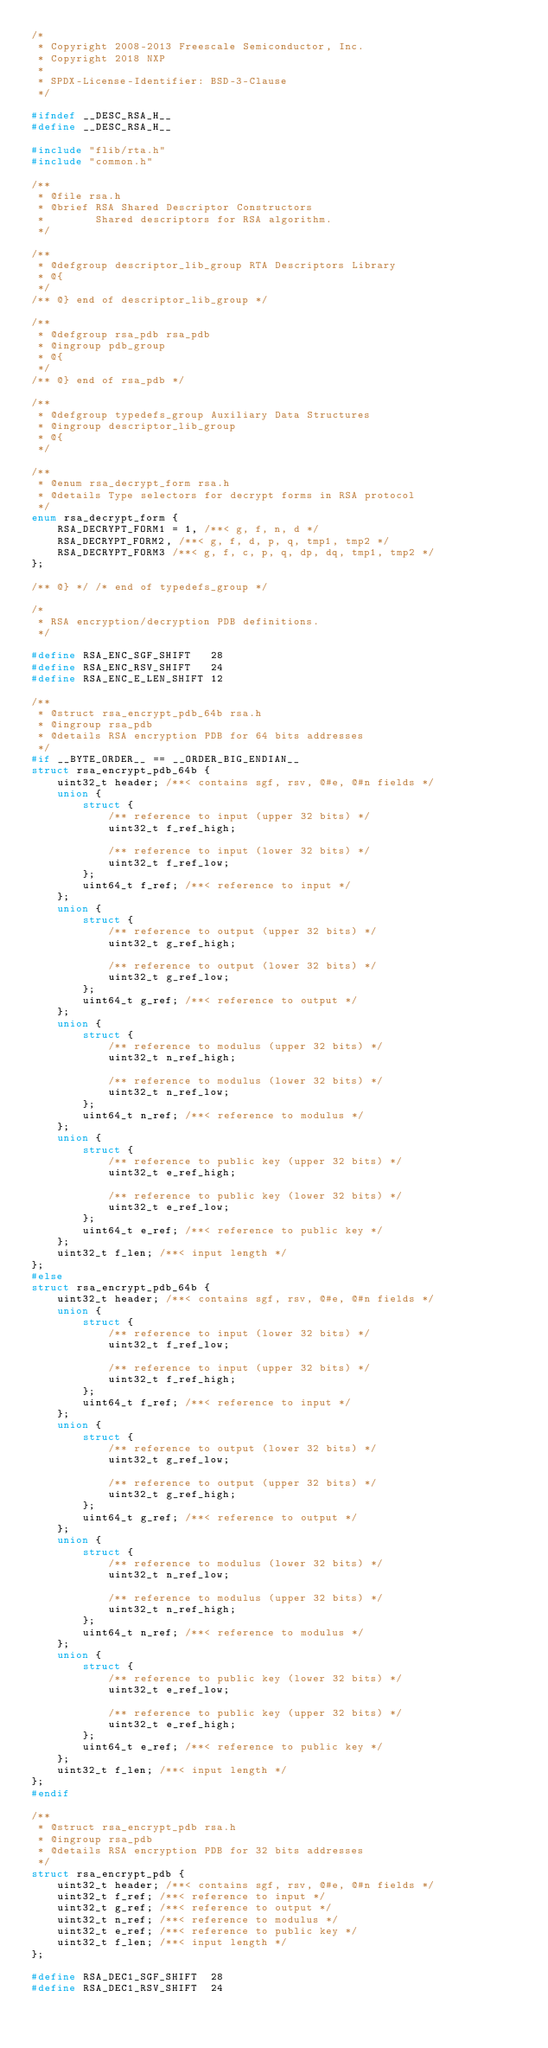<code> <loc_0><loc_0><loc_500><loc_500><_C_>/*
 * Copyright 2008-2013 Freescale Semiconductor, Inc.
 * Copyright 2018 NXP
 *
 * SPDX-License-Identifier: BSD-3-Clause
 */

#ifndef __DESC_RSA_H__
#define __DESC_RSA_H__

#include "flib/rta.h"
#include "common.h"

/**
 * @file rsa.h
 * @brief RSA Shared Descriptor Constructors
 *        Shared descriptors for RSA algorithm.
 */

/**
 * @defgroup descriptor_lib_group RTA Descriptors Library
 * @{
 */
/** @} end of descriptor_lib_group */

/**
 * @defgroup rsa_pdb rsa_pdb
 * @ingroup pdb_group
 * @{
 */
/** @} end of rsa_pdb */

/**
 * @defgroup typedefs_group Auxiliary Data Structures
 * @ingroup descriptor_lib_group
 * @{
 */

/**
 * @enum rsa_decrypt_form rsa.h
 * @details Type selectors for decrypt forms in RSA protocol
 */
enum rsa_decrypt_form {
	RSA_DECRYPT_FORM1 = 1, /**< g, f, n, d */
	RSA_DECRYPT_FORM2, /**< g, f, d, p, q, tmp1, tmp2 */
	RSA_DECRYPT_FORM3 /**< g, f, c, p, q, dp, dq, tmp1, tmp2 */
};

/** @} */ /* end of typedefs_group */

/*
 * RSA encryption/decryption PDB definitions.
 */

#define RSA_ENC_SGF_SHIFT	28
#define RSA_ENC_RSV_SHIFT	24
#define RSA_ENC_E_LEN_SHIFT	12

/**
 * @struct rsa_encrypt_pdb_64b rsa.h
 * @ingroup rsa_pdb
 * @details RSA encryption PDB for 64 bits addresses
 */
#if __BYTE_ORDER__ == __ORDER_BIG_ENDIAN__
struct rsa_encrypt_pdb_64b {
	uint32_t header; /**< contains sgf, rsv, @#e, @#n fields */
	union {
		struct {
			/** reference to input (upper 32 bits) */
			uint32_t f_ref_high;

			/** reference to input (lower 32 bits) */
			uint32_t f_ref_low;
		};
		uint64_t f_ref; /**< reference to input */
	};
	union {
		struct {
			/** reference to output (upper 32 bits) */
			uint32_t g_ref_high;

			/** reference to output (lower 32 bits) */
			uint32_t g_ref_low;
		};
		uint64_t g_ref; /**< reference to output */
	};
	union {
		struct {
			/** reference to modulus (upper 32 bits) */
			uint32_t n_ref_high;

			/** reference to modulus (lower 32 bits) */
			uint32_t n_ref_low;
		};
		uint64_t n_ref; /**< reference to modulus */
	};
	union {
		struct {
			/** reference to public key (upper 32 bits) */
			uint32_t e_ref_high;

			/** reference to public key (lower 32 bits) */
			uint32_t e_ref_low;
		};
		uint64_t e_ref; /**< reference to public key */
	};
	uint32_t f_len; /**< input length */
};
#else
struct rsa_encrypt_pdb_64b {
	uint32_t header; /**< contains sgf, rsv, @#e, @#n fields */
	union {
		struct {
			/** reference to input (lower 32 bits) */
			uint32_t f_ref_low;

			/** reference to input (upper 32 bits) */
			uint32_t f_ref_high;
		};
		uint64_t f_ref; /**< reference to input */
	};
	union {
		struct {
			/** reference to output (lower 32 bits) */
			uint32_t g_ref_low;

			/** reference to output (upper 32 bits) */
			uint32_t g_ref_high;
		};
		uint64_t g_ref; /**< reference to output */
	};
	union {
		struct {
			/** reference to modulus (lower 32 bits) */
			uint32_t n_ref_low;

			/** reference to modulus (upper 32 bits) */
			uint32_t n_ref_high;
		};
		uint64_t n_ref; /**< reference to modulus */
	};
	union {
		struct {
			/** reference to public key (lower 32 bits) */
			uint32_t e_ref_low;

			/** reference to public key (upper 32 bits) */
			uint32_t e_ref_high;
		};
		uint64_t e_ref; /**< reference to public key */
	};
	uint32_t f_len; /**< input length */
};
#endif

/**
 * @struct rsa_encrypt_pdb rsa.h
 * @ingroup rsa_pdb
 * @details RSA encryption PDB for 32 bits addresses
 */
struct rsa_encrypt_pdb {
	uint32_t header; /**< contains sgf, rsv, @#e, @#n fields */
	uint32_t f_ref; /**< reference to input */
	uint32_t g_ref; /**< reference to output */
	uint32_t n_ref; /**< reference to modulus */
	uint32_t e_ref; /**< reference to public key */
	uint32_t f_len; /**< input length */
};

#define RSA_DEC1_SGF_SHIFT	28
#define RSA_DEC1_RSV_SHIFT	24</code> 